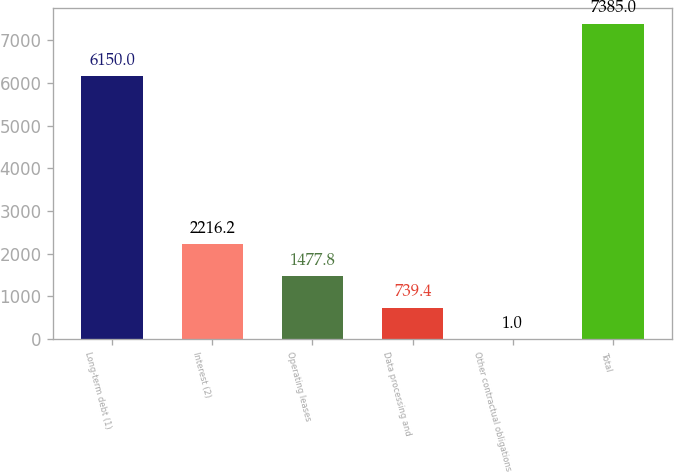<chart> <loc_0><loc_0><loc_500><loc_500><bar_chart><fcel>Long-term debt (1)<fcel>Interest (2)<fcel>Operating leases<fcel>Data processing and<fcel>Other contractual obligations<fcel>Total<nl><fcel>6150<fcel>2216.2<fcel>1477.8<fcel>739.4<fcel>1<fcel>7385<nl></chart> 